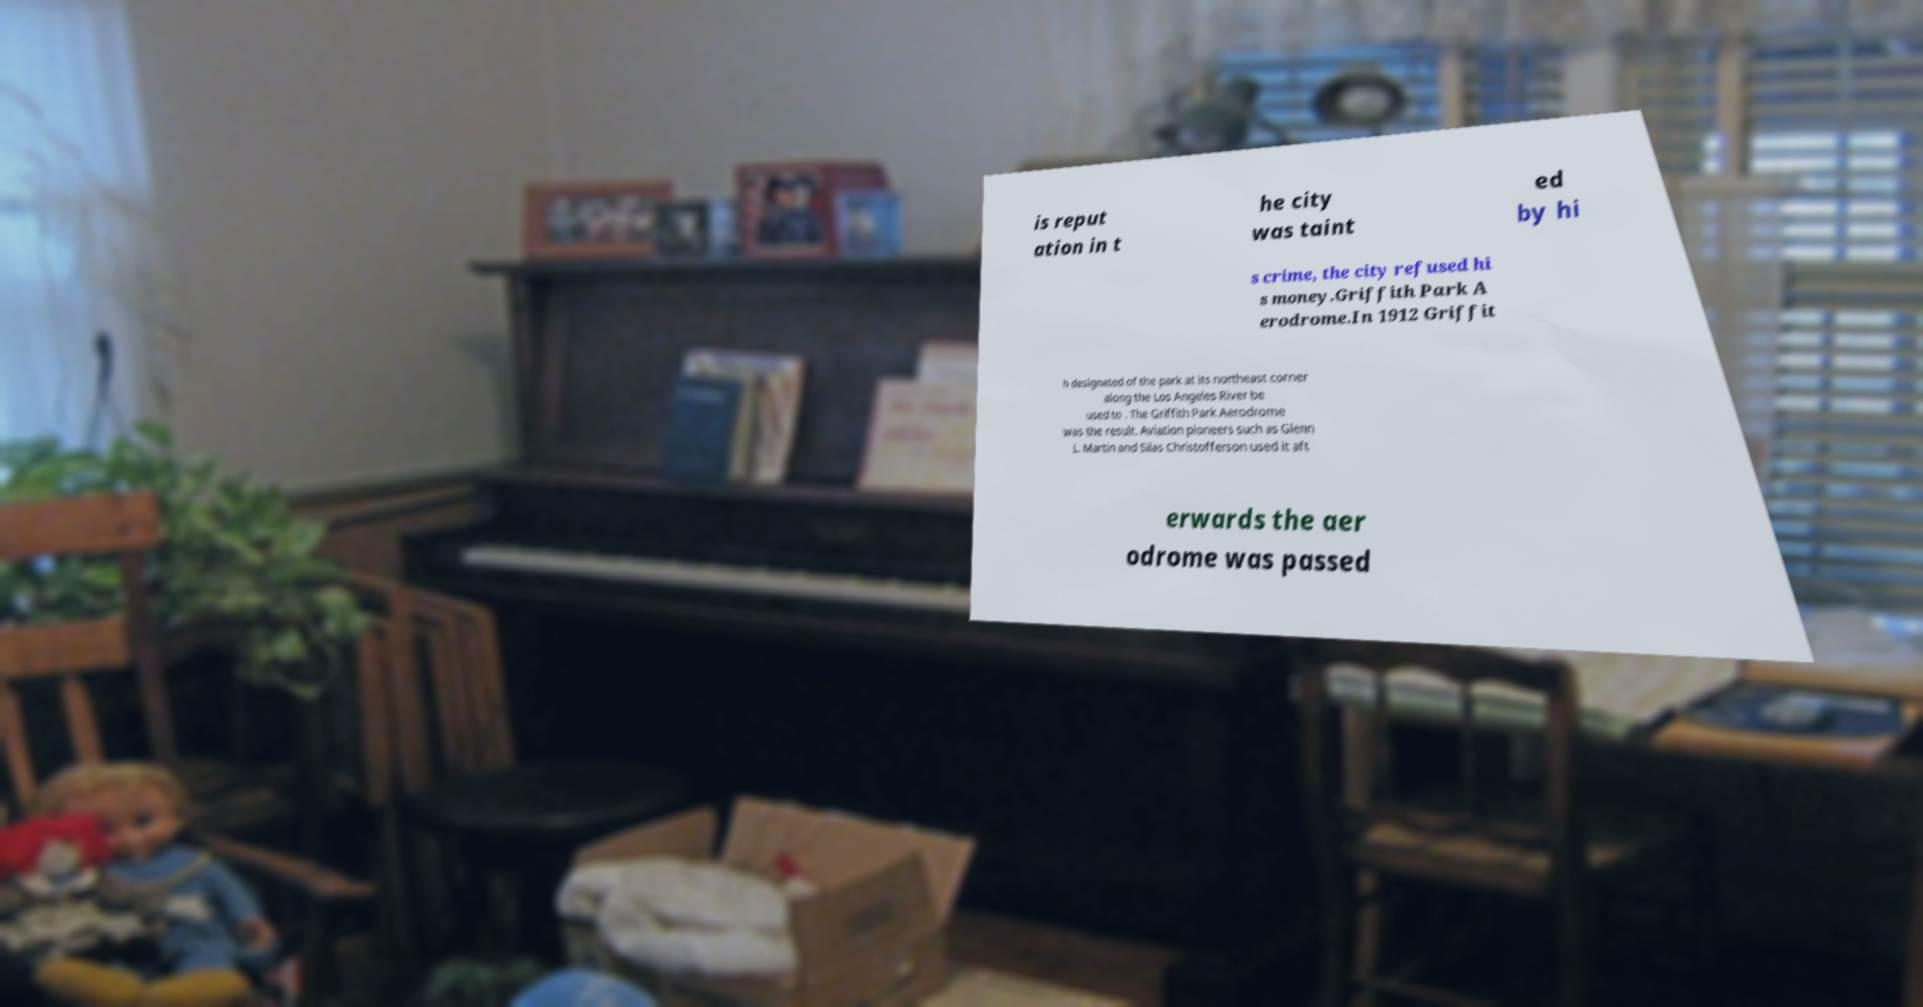Can you read and provide the text displayed in the image?This photo seems to have some interesting text. Can you extract and type it out for me? is reput ation in t he city was taint ed by hi s crime, the city refused hi s money.Griffith Park A erodrome.In 1912 Griffit h designated of the park at its northeast corner along the Los Angeles River be used to . The Griffith Park Aerodrome was the result. Aviation pioneers such as Glenn L. Martin and Silas Christofferson used it aft erwards the aer odrome was passed 